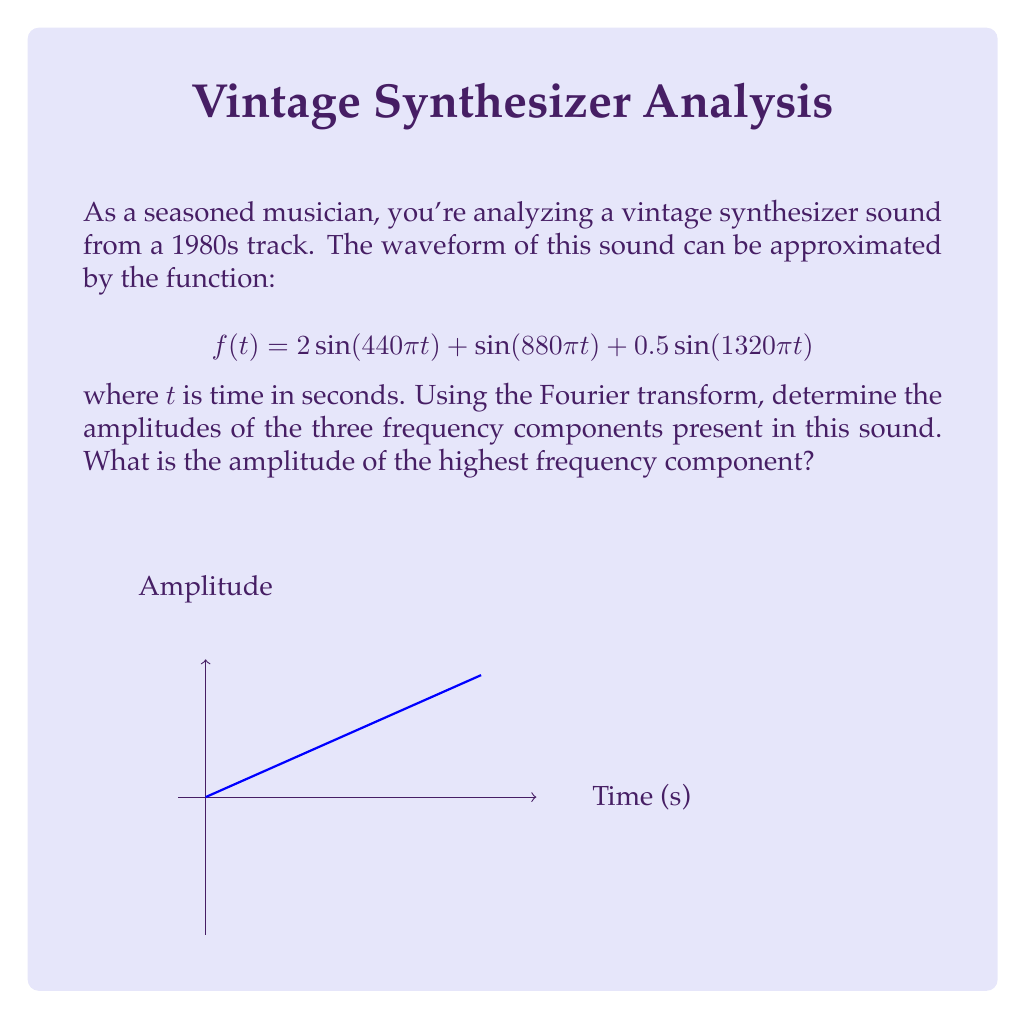Can you solve this math problem? To solve this problem, we'll follow these steps:

1) Recall that the Fourier transform of a sinusoidal function $a\sin(2\pi ft)$ is a pair of delta functions at frequencies $\pm f$ with amplitude $a/2$.

2) In our function $f(t)$, we have three sinusoidal components:

   a) $2\sin(440\pi t)$ which is equivalent to $2\sin(2\pi \cdot 220t)$
   b) $\sin(880\pi t)$ which is equivalent to $\sin(2\pi \cdot 440t)$
   c) $0.5\sin(1320\pi t)$ which is equivalent to $0.5\sin(2\pi \cdot 660t)$

3) The frequencies are 220 Hz, 440 Hz, and 660 Hz respectively.

4) The amplitudes in the frequency domain will be half of the time domain amplitudes:

   a) For 220 Hz: $2/2 = 1$
   b) For 440 Hz: $1/2 = 0.5$
   c) For 660 Hz: $0.5/2 = 0.25$

5) Therefore, the Fourier transform will have peaks at these three frequencies with these amplitudes.

6) The highest frequency component is 660 Hz, which has an amplitude of 0.25 in the frequency domain.
Answer: 0.25 